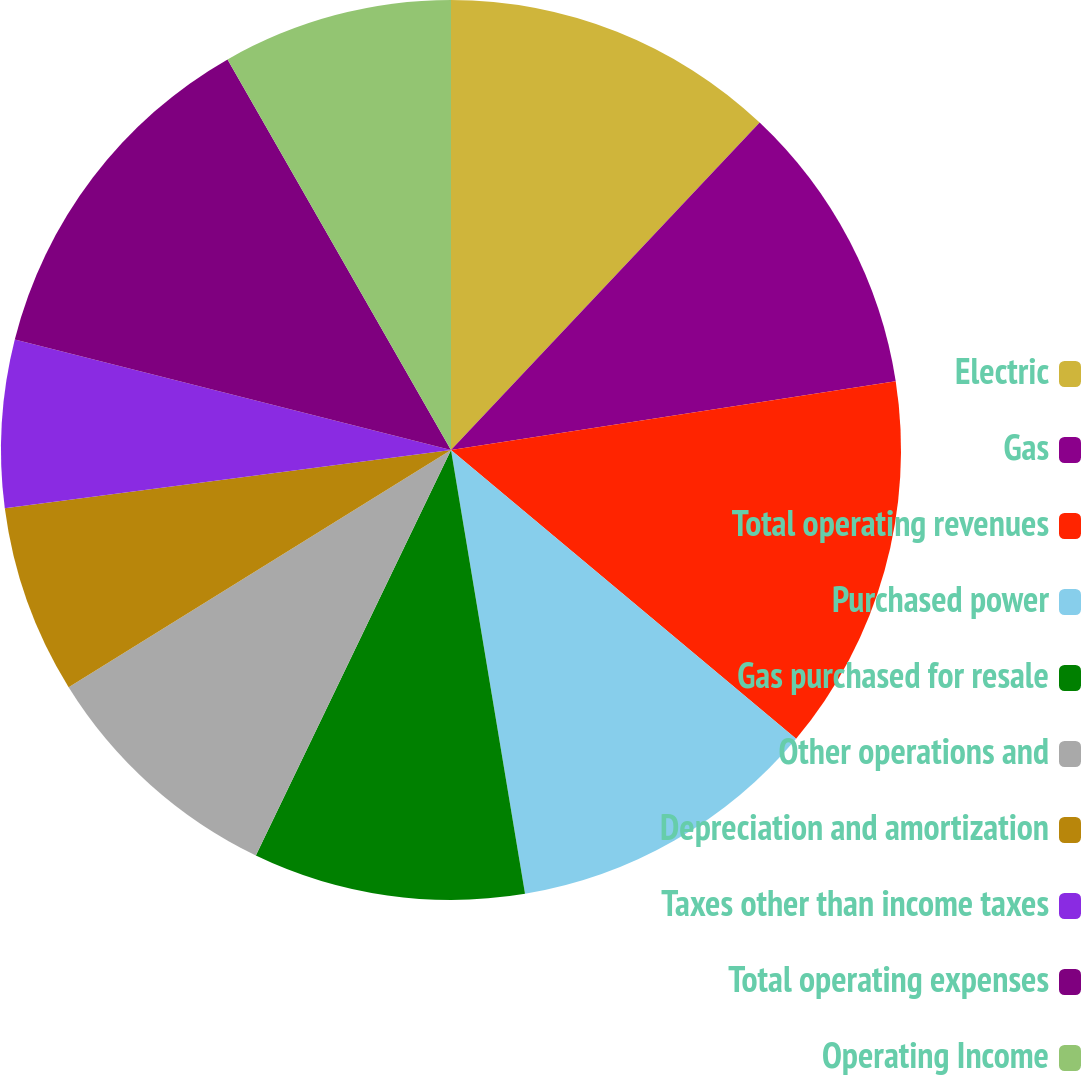Convert chart. <chart><loc_0><loc_0><loc_500><loc_500><pie_chart><fcel>Electric<fcel>Gas<fcel>Total operating revenues<fcel>Purchased power<fcel>Gas purchased for resale<fcel>Other operations and<fcel>Depreciation and amortization<fcel>Taxes other than income taxes<fcel>Total operating expenses<fcel>Operating Income<nl><fcel>12.03%<fcel>10.53%<fcel>13.53%<fcel>11.28%<fcel>9.77%<fcel>9.02%<fcel>6.77%<fcel>6.02%<fcel>12.78%<fcel>8.27%<nl></chart> 